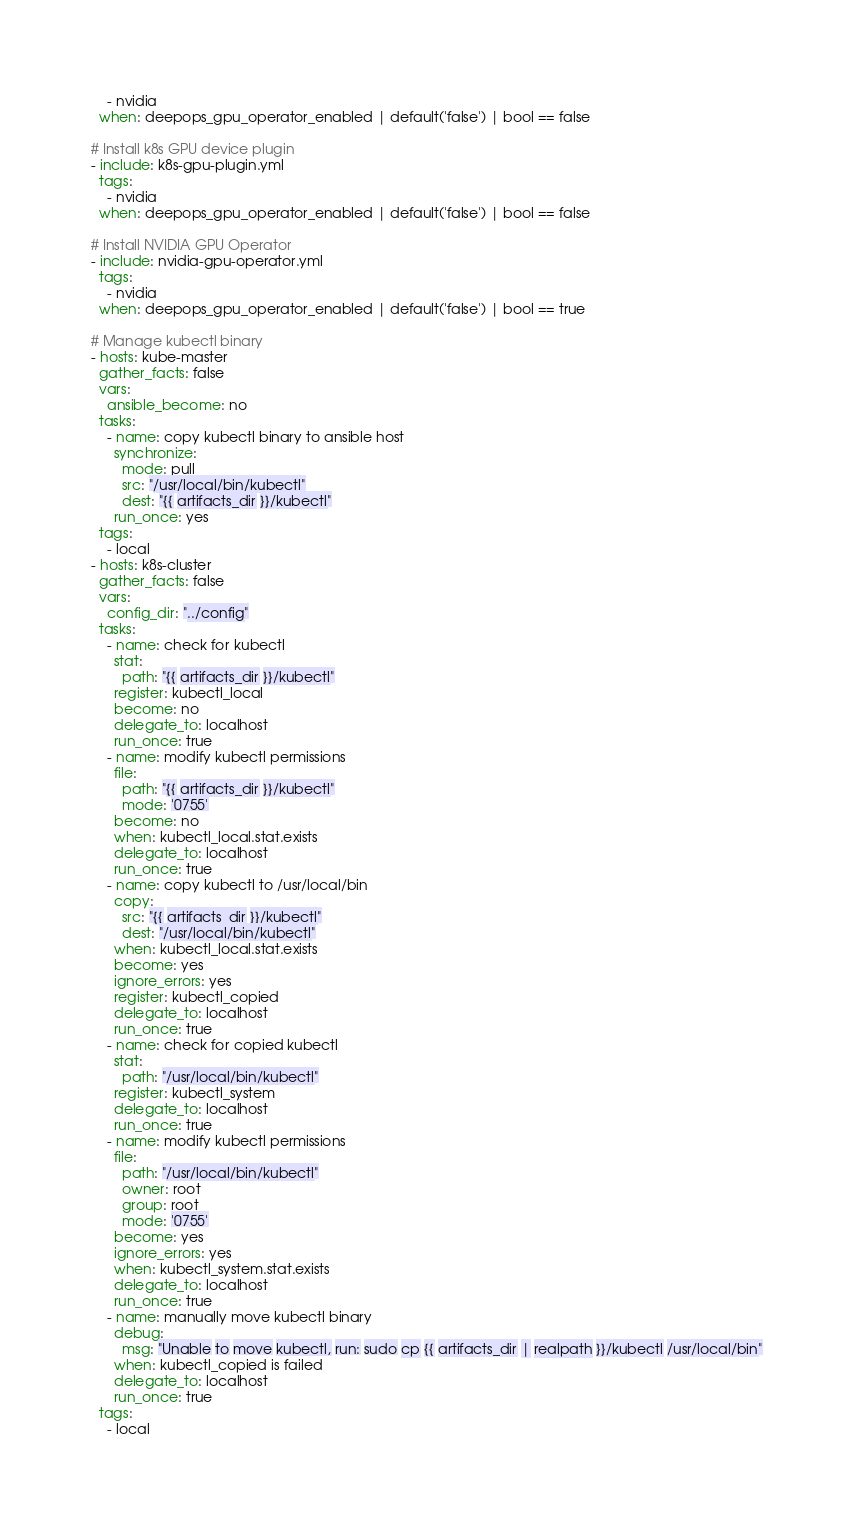<code> <loc_0><loc_0><loc_500><loc_500><_YAML_>    - nvidia
  when: deepops_gpu_operator_enabled | default('false') | bool == false

# Install k8s GPU device plugin
- include: k8s-gpu-plugin.yml
  tags:
    - nvidia
  when: deepops_gpu_operator_enabled | default('false') | bool == false

# Install NVIDIA GPU Operator
- include: nvidia-gpu-operator.yml
  tags:
    - nvidia
  when: deepops_gpu_operator_enabled | default('false') | bool == true

# Manage kubectl binary
- hosts: kube-master
  gather_facts: false
  vars:
    ansible_become: no
  tasks:
    - name: copy kubectl binary to ansible host
      synchronize:
        mode: pull
        src: "/usr/local/bin/kubectl"
        dest: "{{ artifacts_dir }}/kubectl"
      run_once: yes
  tags:
    - local
- hosts: k8s-cluster
  gather_facts: false
  vars:
    config_dir: "../config"
  tasks:
    - name: check for kubectl
      stat:
        path: "{{ artifacts_dir }}/kubectl"
      register: kubectl_local
      become: no
      delegate_to: localhost
      run_once: true
    - name: modify kubectl permissions
      file:
        path: "{{ artifacts_dir }}/kubectl"
        mode: '0755'
      become: no
      when: kubectl_local.stat.exists
      delegate_to: localhost
      run_once: true
    - name: copy kubectl to /usr/local/bin
      copy:
        src: "{{ artifacts_dir }}/kubectl"
        dest: "/usr/local/bin/kubectl"
      when: kubectl_local.stat.exists
      become: yes
      ignore_errors: yes
      register: kubectl_copied
      delegate_to: localhost
      run_once: true
    - name: check for copied kubectl
      stat:
        path: "/usr/local/bin/kubectl"
      register: kubectl_system
      delegate_to: localhost
      run_once: true
    - name: modify kubectl permissions
      file:
        path: "/usr/local/bin/kubectl"
        owner: root
        group: root
        mode: '0755'
      become: yes
      ignore_errors: yes
      when: kubectl_system.stat.exists
      delegate_to: localhost
      run_once: true
    - name: manually move kubectl binary
      debug:
        msg: "Unable to move kubectl, run: sudo cp {{ artifacts_dir | realpath }}/kubectl /usr/local/bin"
      when: kubectl_copied is failed
      delegate_to: localhost
      run_once: true
  tags:
    - local


</code> 